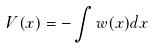Convert formula to latex. <formula><loc_0><loc_0><loc_500><loc_500>V ( x ) = - \int w ( x ) d x</formula> 